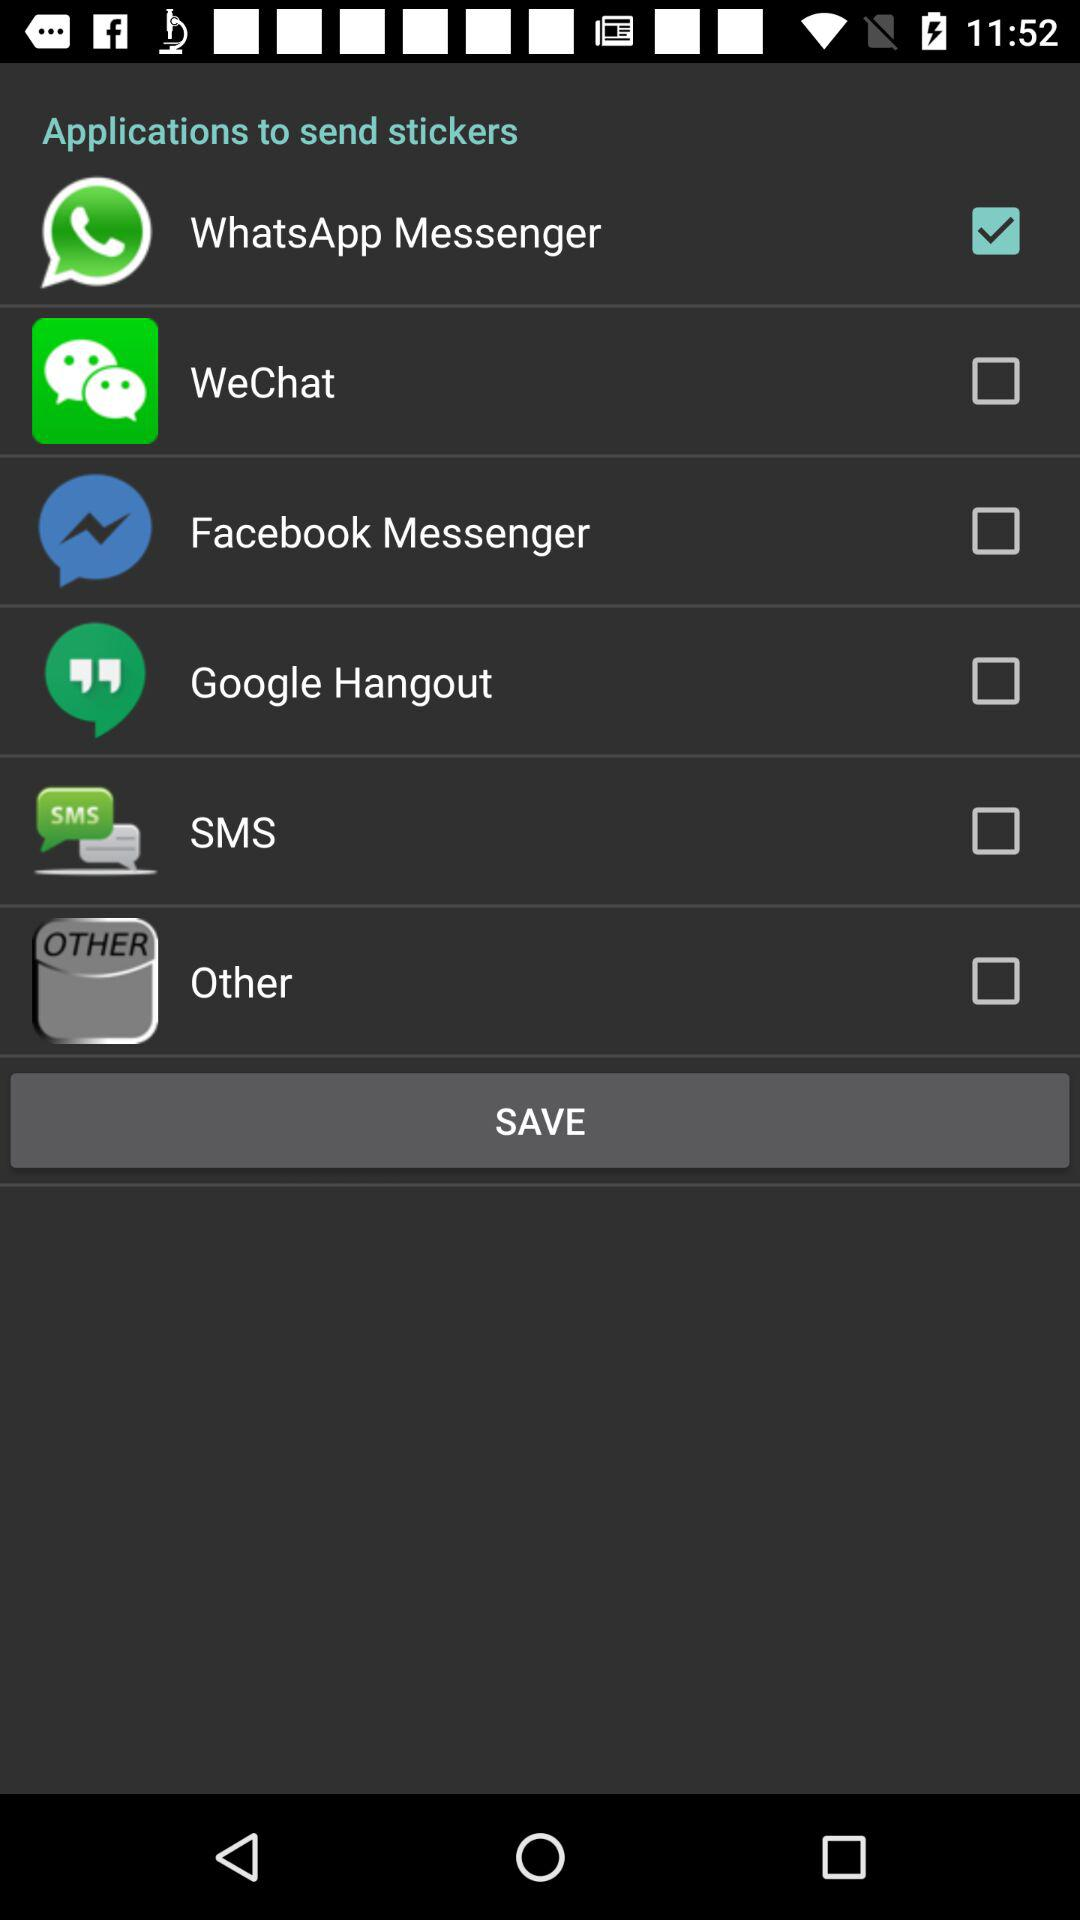What is the status of "WeChat"? The status is "off". 